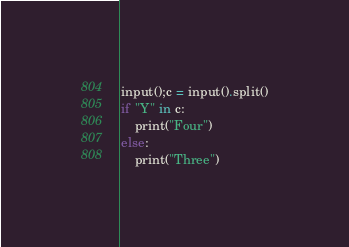Convert code to text. <code><loc_0><loc_0><loc_500><loc_500><_Python_>input();c = input().split()
if "Y" in c:
    print("Four")
else:
    print("Three")</code> 